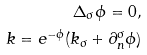<formula> <loc_0><loc_0><loc_500><loc_500>\Delta _ { \sigma } \phi = 0 , \\ k = e ^ { - \phi } ( k _ { \sigma } + \partial _ { n } ^ { \sigma } \phi )</formula> 